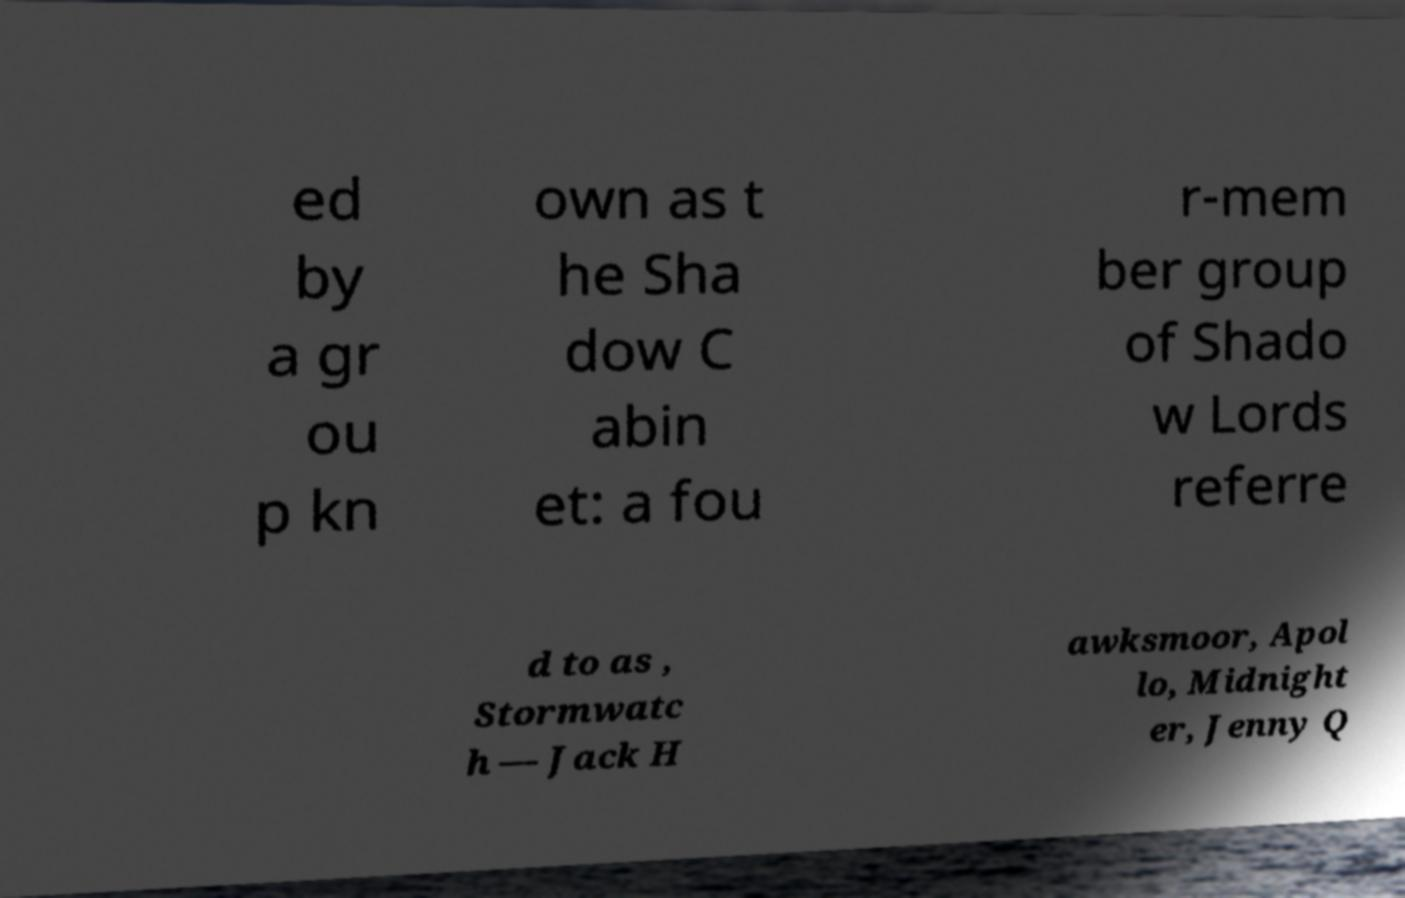Can you read and provide the text displayed in the image?This photo seems to have some interesting text. Can you extract and type it out for me? ed by a gr ou p kn own as t he Sha dow C abin et: a fou r-mem ber group of Shado w Lords referre d to as , Stormwatc h — Jack H awksmoor, Apol lo, Midnight er, Jenny Q 